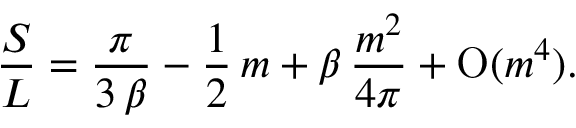<formula> <loc_0><loc_0><loc_500><loc_500>{ \frac { S } { L } } = { \frac { \pi } { 3 \, \beta } } - { \frac { 1 } { 2 } } \, m + \beta \, { \frac { m ^ { 2 } } { 4 \pi } } + O ( m ^ { 4 } ) .</formula> 